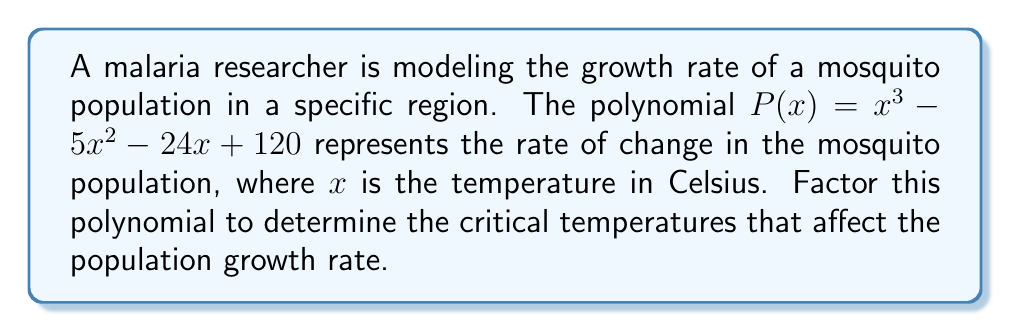Solve this math problem. To factor this polynomial, we'll follow these steps:

1) First, let's check if there's a common factor. In this case, there isn't.

2) This is a cubic polynomial. Let's try to find a factor by guessing roots. The possible rational roots are the factors of the constant term (120): ±1, ±2, ±3, ±4, ±5, ±6, ±8, ±10, ±12, ±15, ±20, ±24, ±30, ±40, ±60, ±120.

3) Testing these values, we find that $P(8) = 0$. So $(x-8)$ is a factor.

4) We can use polynomial long division to find the other factor:

   $$\frac{x^3 - 5x^2 - 24x + 120}{x - 8} = x^2 + 3x - 15$$

5) Now we have: $P(x) = (x-8)(x^2 + 3x - 15)$

6) We can factor the quadratic term $(x^2 + 3x - 15)$ further:
   - The factors of -15 that add up to 3 are 8 and -5
   - So, $x^2 + 3x - 15 = (x+8)(x-5)$

7) Therefore, the fully factored polynomial is:

   $$P(x) = (x-8)(x+8)(x-5)$$

This factorization reveals that the critical temperatures affecting the mosquito population growth rate are 8°C, -8°C, and 5°C.
Answer: $P(x) = (x-8)(x+8)(x-5)$ 